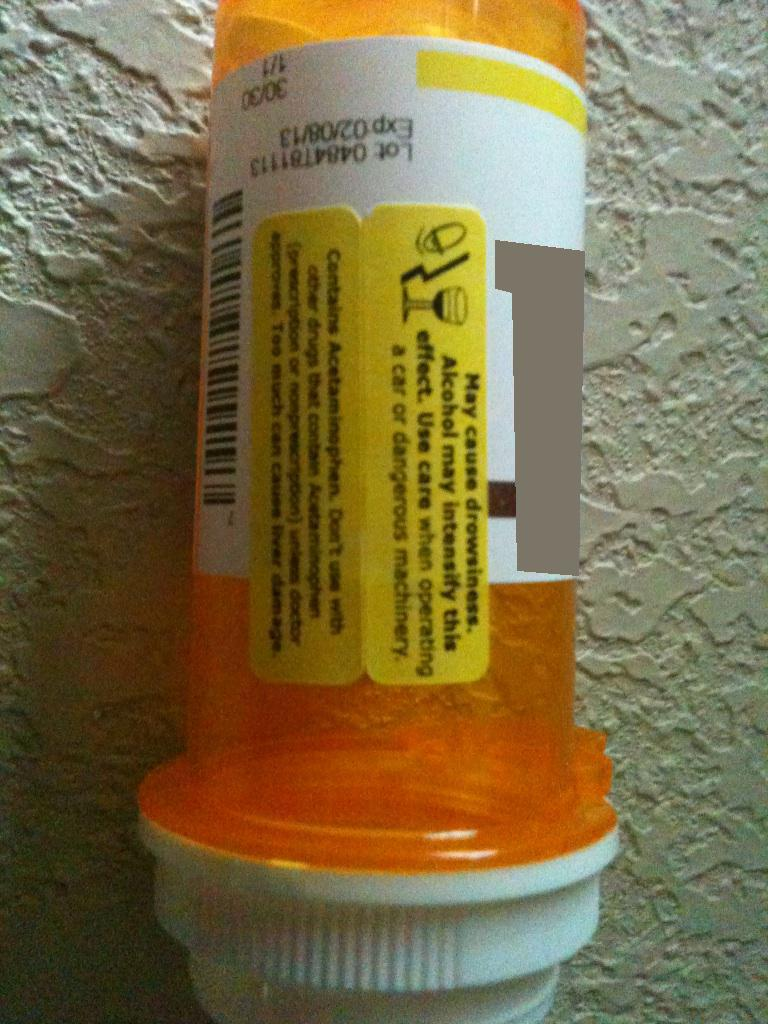Could you describe a realistic scenario where following the label's advice is crucial? Imagine Sarah, who has a demanding job as a forklift operator. She recently injured her back and was prescribed medication that includes acetaminophen. Knowing the critical nature of her job and the risks involved in operating heavy machinery, she carefully reads the warning label, recognizing the importance of its caution. Dutifully, she avoids alcohol and ensures she’s fully alert before a shift, understanding that even slight drowsiness could lead to dangerous mishaps. By adhering to the label’s guidance, Sarah mitigates the risk of accidents at her workplace, ensuring both her safety and that of her coworkers.  What might happen if someone ignores the warning about exceeding the recommended dosage? If someone ignores the warning about exceeding the recommended dosage of acetaminophen, they face serious health risks. Acetaminophen overdose is a leading cause of acute liver failure, which can be life-threatening. Symptoms of overdose might include nausea, vomiting, loss of appetite, confusion, and abdominal pain. In severe cases, it can lead to liver damage requiring hospitalization, liver transplantation, or even resulting in death. Thus, it is vital to adhere to the recommended dose and avoid simultaneously taking other medications containing acetaminophen. 